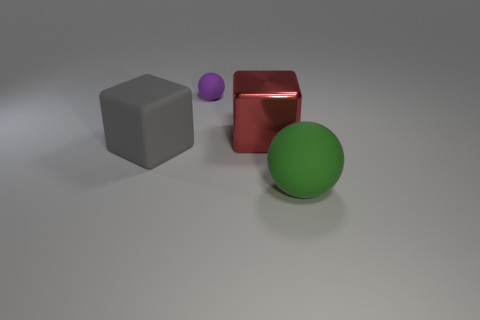Is the number of small purple spheres that are to the right of the green matte sphere the same as the number of matte spheres in front of the small purple matte thing? Upon review, the answer 'no' is correct but lacks detail. To clarify, there are no purple spheres directly to the right of the green matte sphere or in front of the small purple matte thing visible in the image. The setup doesn't quite match the scenario described in the question. 